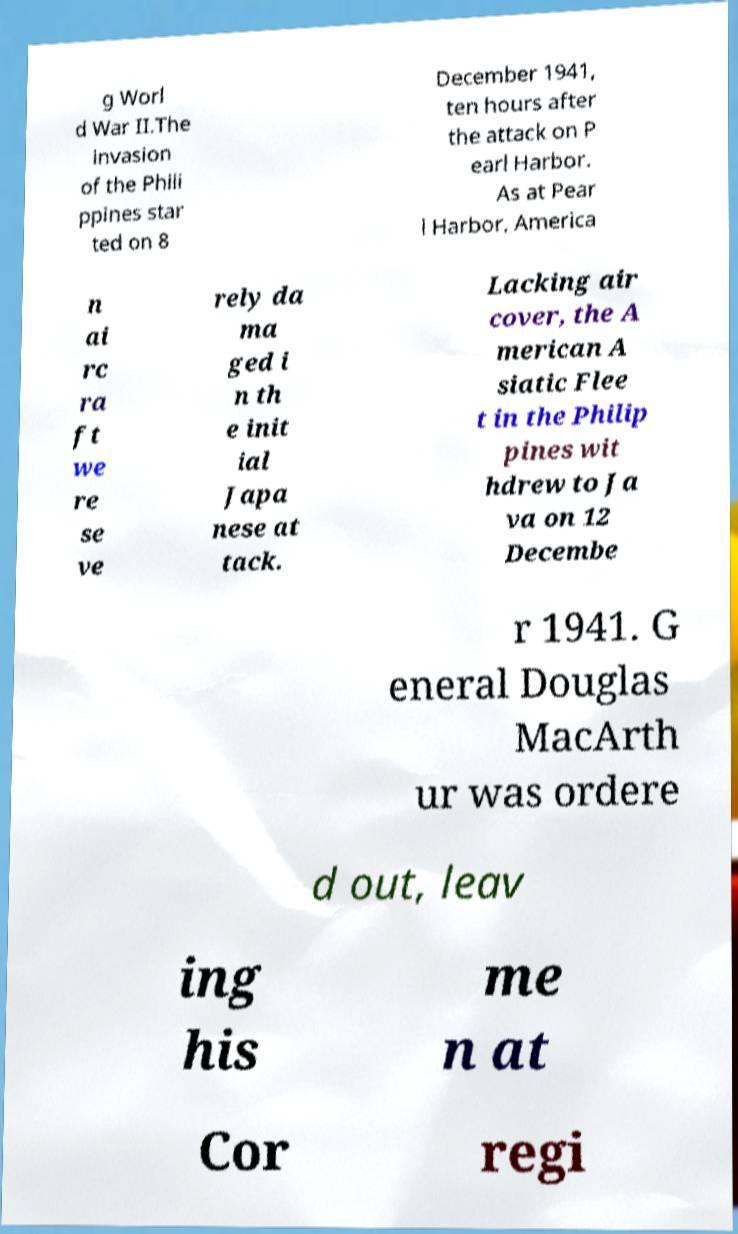Can you accurately transcribe the text from the provided image for me? g Worl d War II.The invasion of the Phili ppines star ted on 8 December 1941, ten hours after the attack on P earl Harbor. As at Pear l Harbor, America n ai rc ra ft we re se ve rely da ma ged i n th e init ial Japa nese at tack. Lacking air cover, the A merican A siatic Flee t in the Philip pines wit hdrew to Ja va on 12 Decembe r 1941. G eneral Douglas MacArth ur was ordere d out, leav ing his me n at Cor regi 